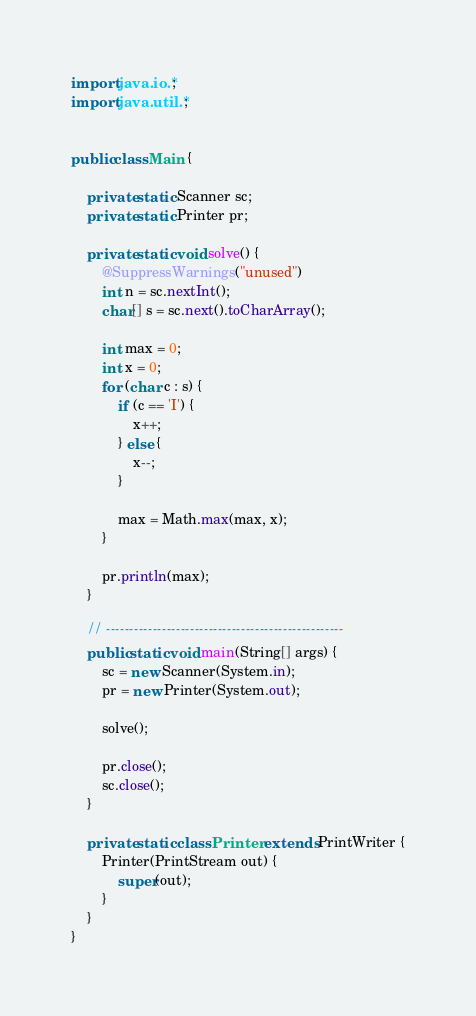Convert code to text. <code><loc_0><loc_0><loc_500><loc_500><_Java_>import java.io.*;
import java.util.*;


public class Main {

	private static Scanner sc;
	private static Printer pr;

	private static void solve() {
		@SuppressWarnings("unused")
		int n = sc.nextInt();
		char[] s = sc.next().toCharArray();

		int max = 0;
		int x = 0;
		for (char c : s) {
			if (c == 'I') {
				x++;
			} else {
				x--;
			}

			max = Math.max(max, x);
		}

		pr.println(max);
	}

	// ---------------------------------------------------
	public static void main(String[] args) {
		sc = new Scanner(System.in);
		pr = new Printer(System.out);

		solve();

		pr.close();
		sc.close();
	}

	private static class Printer extends PrintWriter {
		Printer(PrintStream out) {
			super(out);
		}
	}
}
</code> 